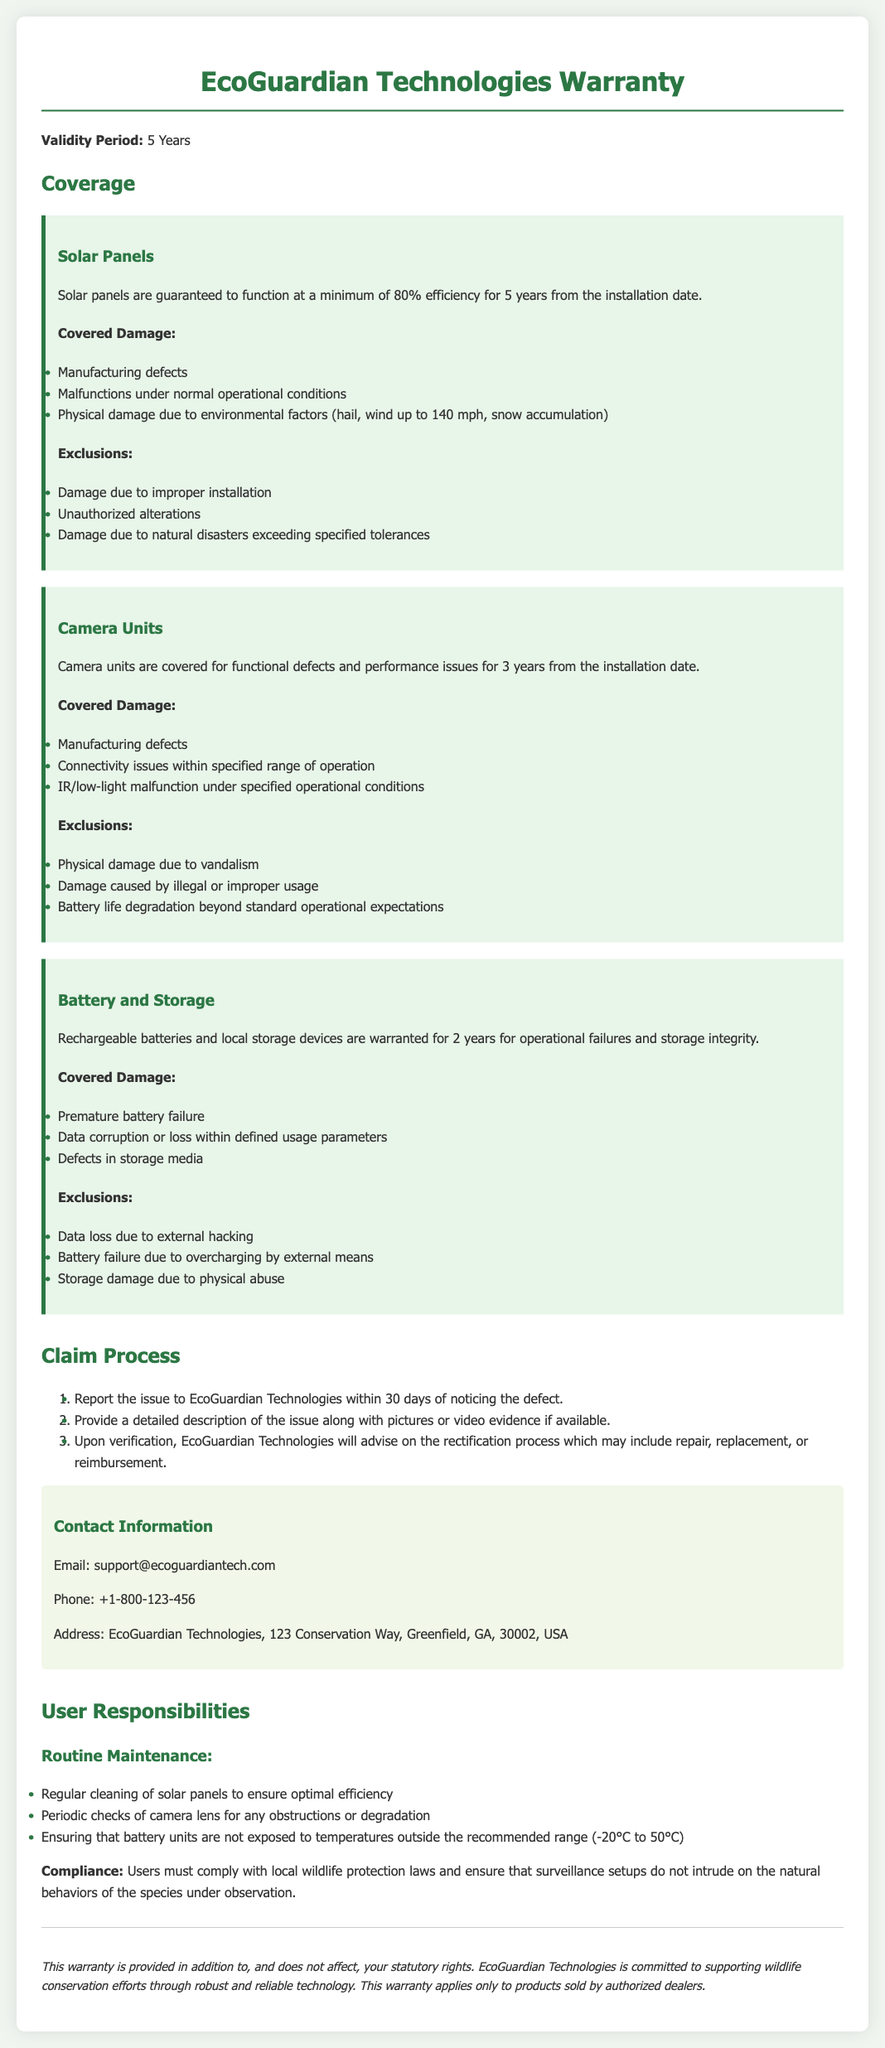What is the validity period of the warranty? The validity period is explicitly stated in the document as 5 years.
Answer: 5 Years What is covered under the solar panels section? This section lists manufacturing defects, malfunctions under normal conditions, and physical damage due to environmental factors as covered damages.
Answer: Manufacturing defects, malfunctions under normal operational conditions, physical damage due to environmental factors How long are camera units covered? The document specifies that camera units are covered for 3 years from the installation date.
Answer: 3 years What must users comply with according to the user responsibilities? The document states that users must comply with local wildlife protection laws.
Answer: Local wildlife protection laws What is the contact email for EcoGuardian Technologies? The document provides a specific email address for support inquiries.
Answer: support@ecoguardiantech.com What should be reported to EcoGuardian Technologies within 30 days? Users are required to report the issue noticed regarding defects within 30 days.
Answer: The issue What happens upon verification of a claim? The document mentions that EcoGuardian Technologies will advise on the rectification process.
Answer: Advise on the rectification process What are users responsible for in terms of routine maintenance? The document outlines regular cleaning of solar panels as a user responsibility.
Answer: Regular cleaning of solar panels 